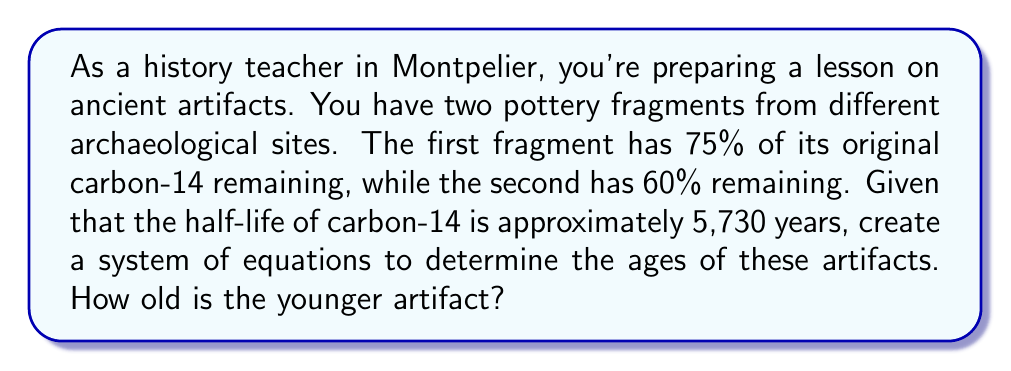Show me your answer to this math problem. Let's approach this step-by-step:

1) Let $x$ be the age of the first artifact and $y$ be the age of the second artifact.

2) The decay of carbon-14 follows the equation:
   $$A = A_0 \cdot (0.5)^{t/5730}$$
   where $A$ is the amount remaining, $A_0$ is the initial amount, and $t$ is time in years.

3) For the first artifact:
   $$0.75 = (0.5)^{x/5730}$$

4) For the second artifact:
   $$0.60 = (0.5)^{y/5730}$$

5) Taking the natural log of both sides for each equation:
   $$\ln(0.75) = \frac{x}{5730} \cdot \ln(0.5)$$
   $$\ln(0.60) = \frac{y}{5730} \cdot \ln(0.5)$$

6) Solving for $x$ and $y$:
   $$x = 5730 \cdot \frac{\ln(0.75)}{\ln(0.5)} \approx 2385 \text{ years}$$
   $$y = 5730 \cdot \frac{\ln(0.60)}{\ln(0.5)} \approx 4270 \text{ years}$$

7) The younger artifact is the first one, which is approximately 2,385 years old.
Answer: 2,385 years 